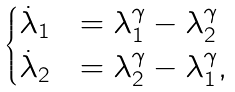<formula> <loc_0><loc_0><loc_500><loc_500>\begin{cases} \dot { \lambda } _ { 1 } & = \lambda _ { 1 } ^ { \gamma } - \lambda _ { 2 } ^ { \gamma } \\ \dot { \lambda } _ { 2 } & = \lambda _ { 2 } ^ { \gamma } - \lambda _ { 1 } ^ { \gamma } , \end{cases}</formula> 